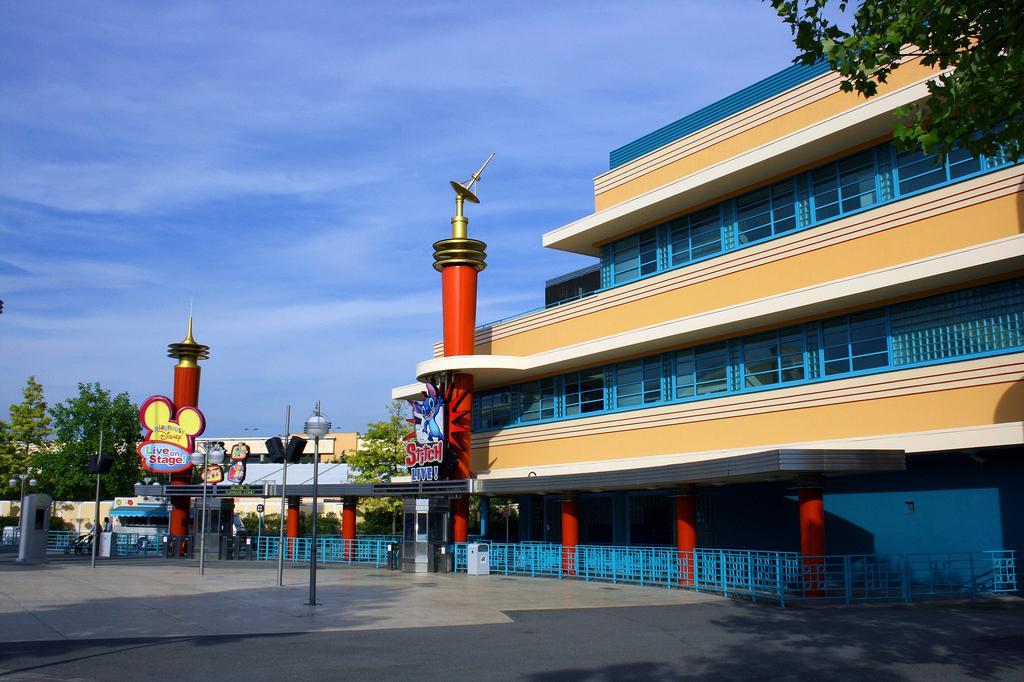Please provide a concise description of this image. In the image in the center we can see poles,fences,banners,vehicles,shops and few people. In the background we can see the sky,clouds,buildings and trees. 